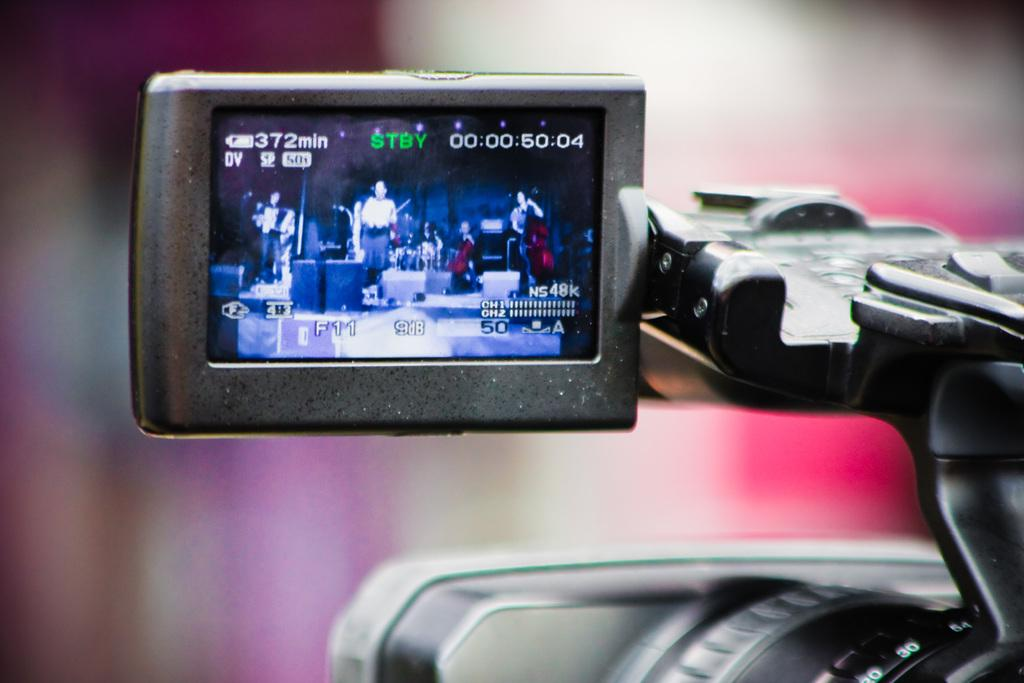What object is the main focus of the image? There is a black color camera in the image. What is the camera doing in the image? The camera displays a picture. What type of jelly can be seen on the brake of the car in the image? There is no car or jelly present in the image; it only features a black color camera displaying a picture. 